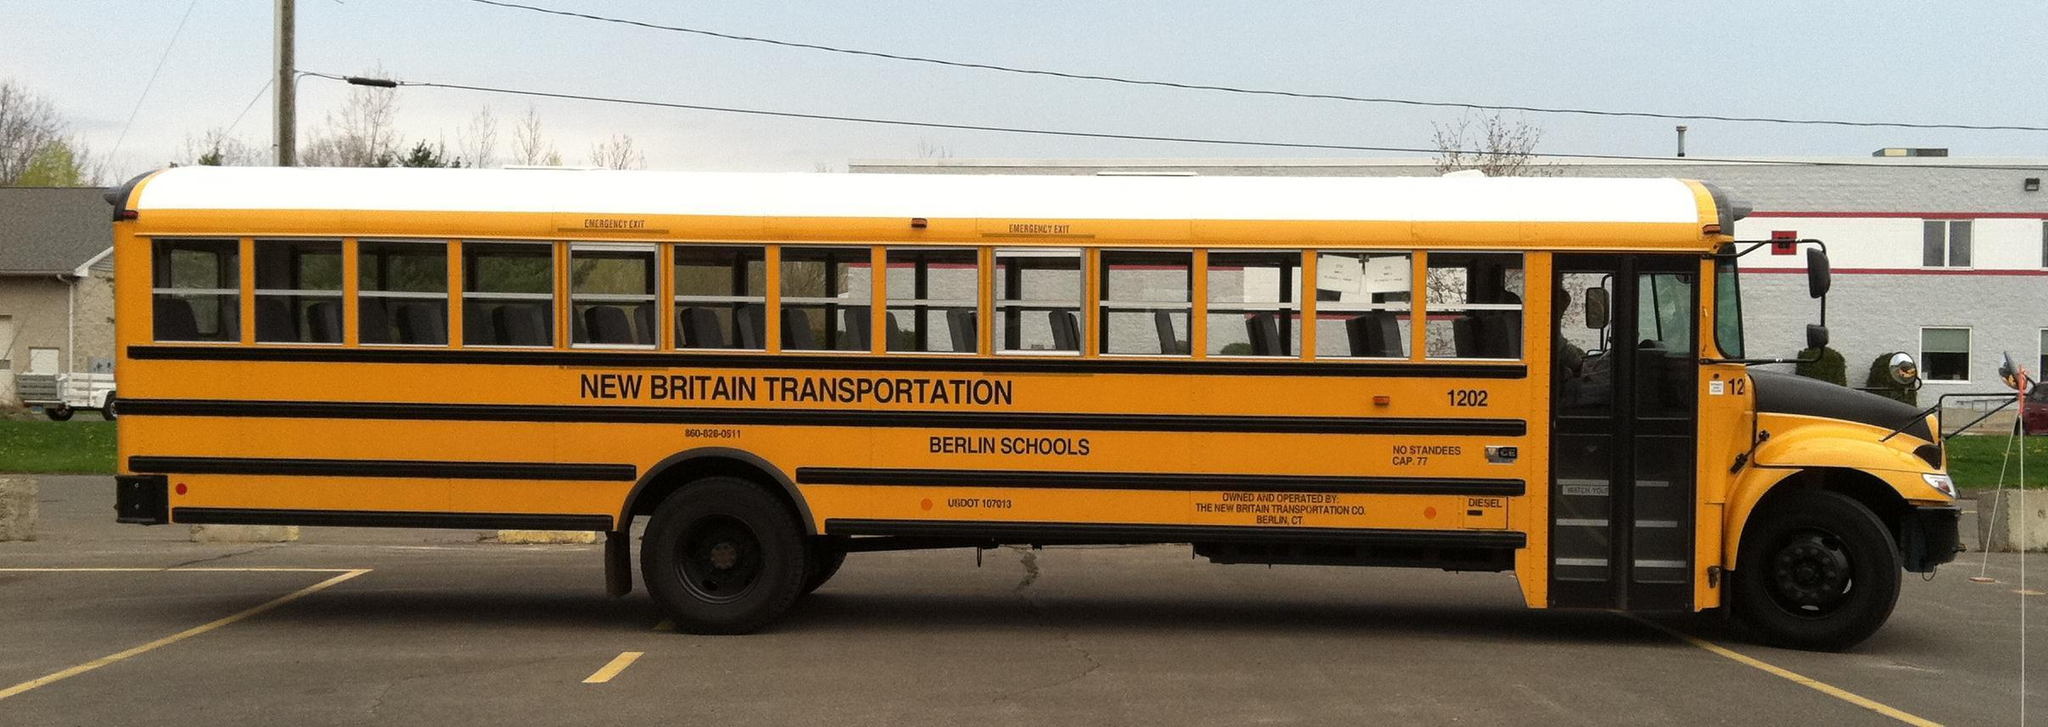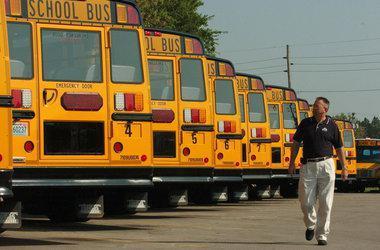The first image is the image on the left, the second image is the image on the right. For the images shown, is this caption "There are more buses in the right image than in the left image." true? Answer yes or no. Yes. 